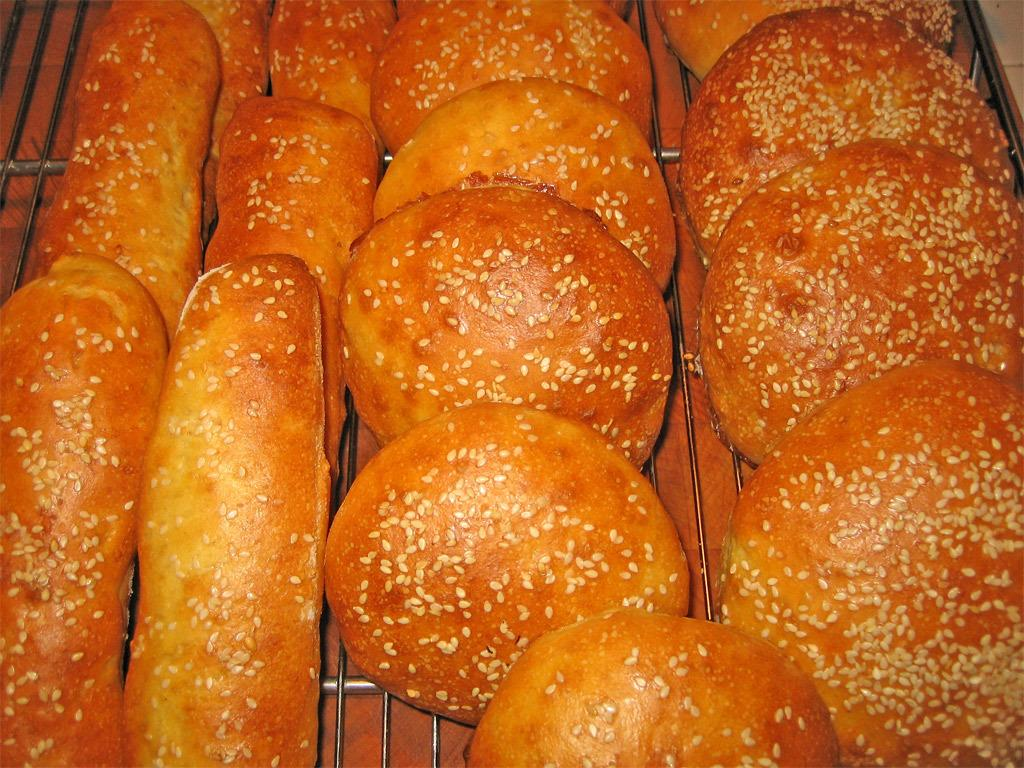What type of food can be seen in the image? There are baked bread slices and hams in the image. How are the bread slices and hams arranged in the image? Both the bread slices and hams are in a tray. What type of twig can be seen in the image? There is no twig present in the image. Is there a bomb visible in the image? No, there is no bomb present in the image. 